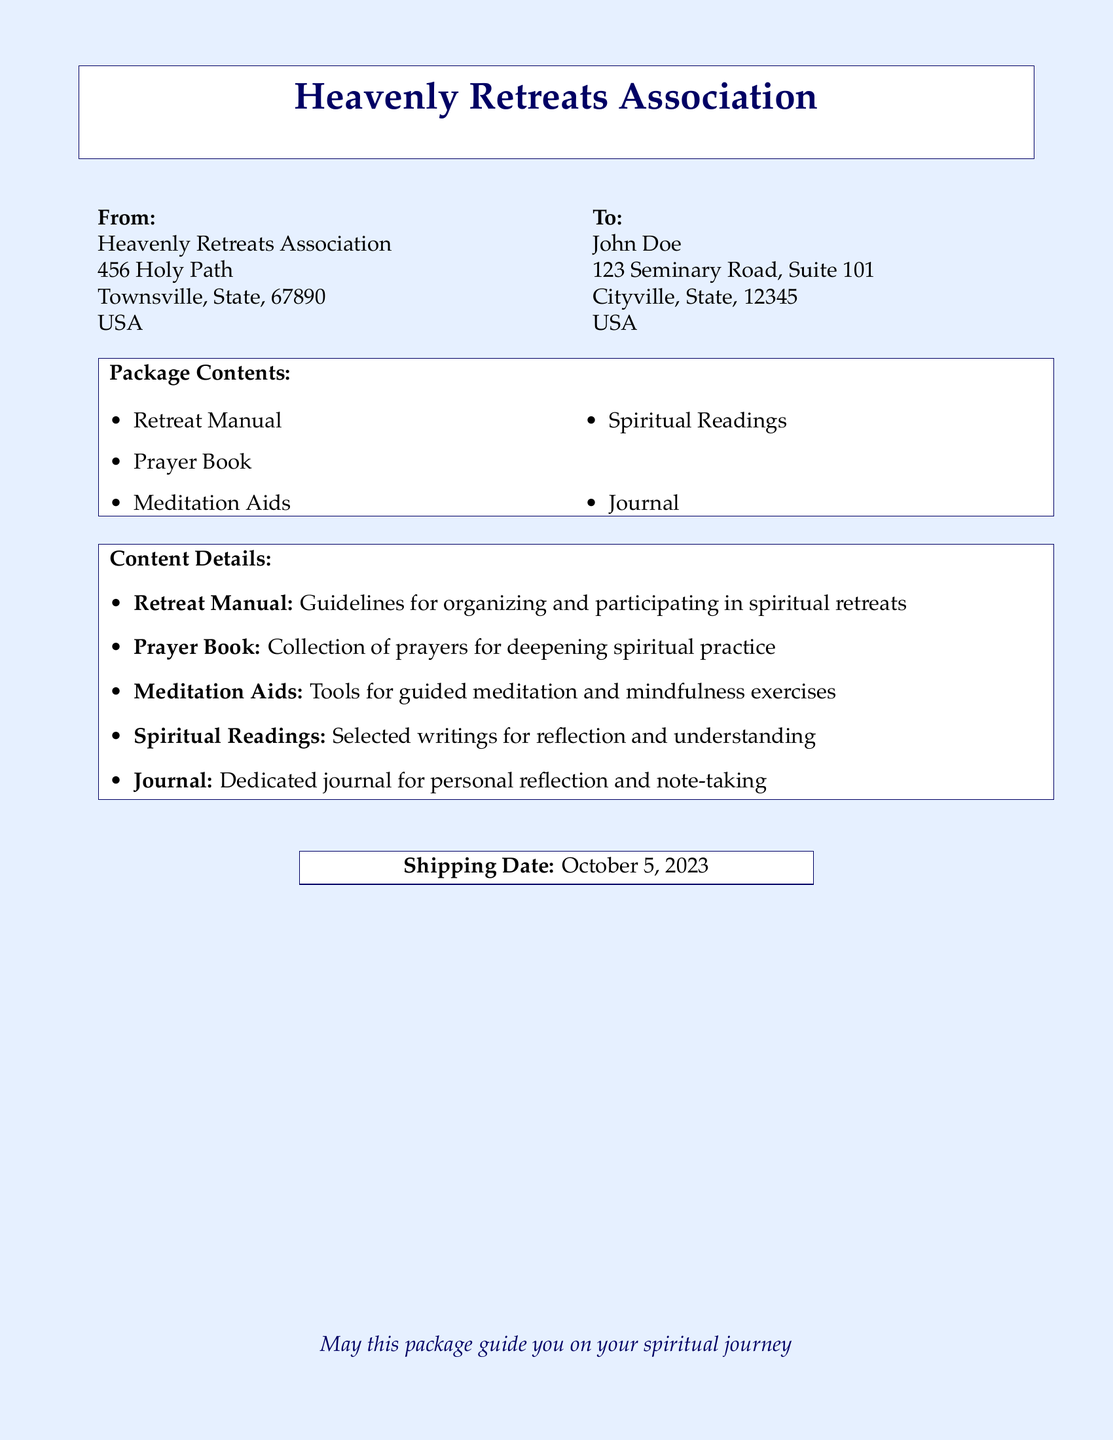What is the name of the organization sending the package? The document states that the package is sent by the "Heavenly Retreats Association."
Answer: Heavenly Retreats Association What is the shipping date? The document clearly indicates that the shipping date is "October 5, 2023."
Answer: October 5, 2023 Who is the recipient of the package? The label specifies "John Doe" as the recipient.
Answer: John Doe What type of book is included in the package? The document lists a "Prayer Book" as one of the contents.
Answer: Prayer Book How many items are listed in the package contents? There are a total of five items outlined in the package contents section of the document.
Answer: Five What is the purpose of the Journal included in the package? The document mentions that the Journal is for "personal reflection and note-taking."
Answer: Personal reflection and note-taking What are the Meditation Aids used for? The contents detail that the Meditation Aids are "tools for guided meditation and mindfulness exercises."
Answer: Guided meditation and mindfulness exercises What kind of readings are included in the package? The document specifies that "Spiritual Readings" are included for reflection and understanding.
Answer: Spiritual Readings Where is the Heavenly Retreats Association located? The address of the Heavenly Retreats Association is specified as "456 Holy Path, Townsville, State, 67890, USA."
Answer: 456 Holy Path, Townsville, State, 67890, USA 